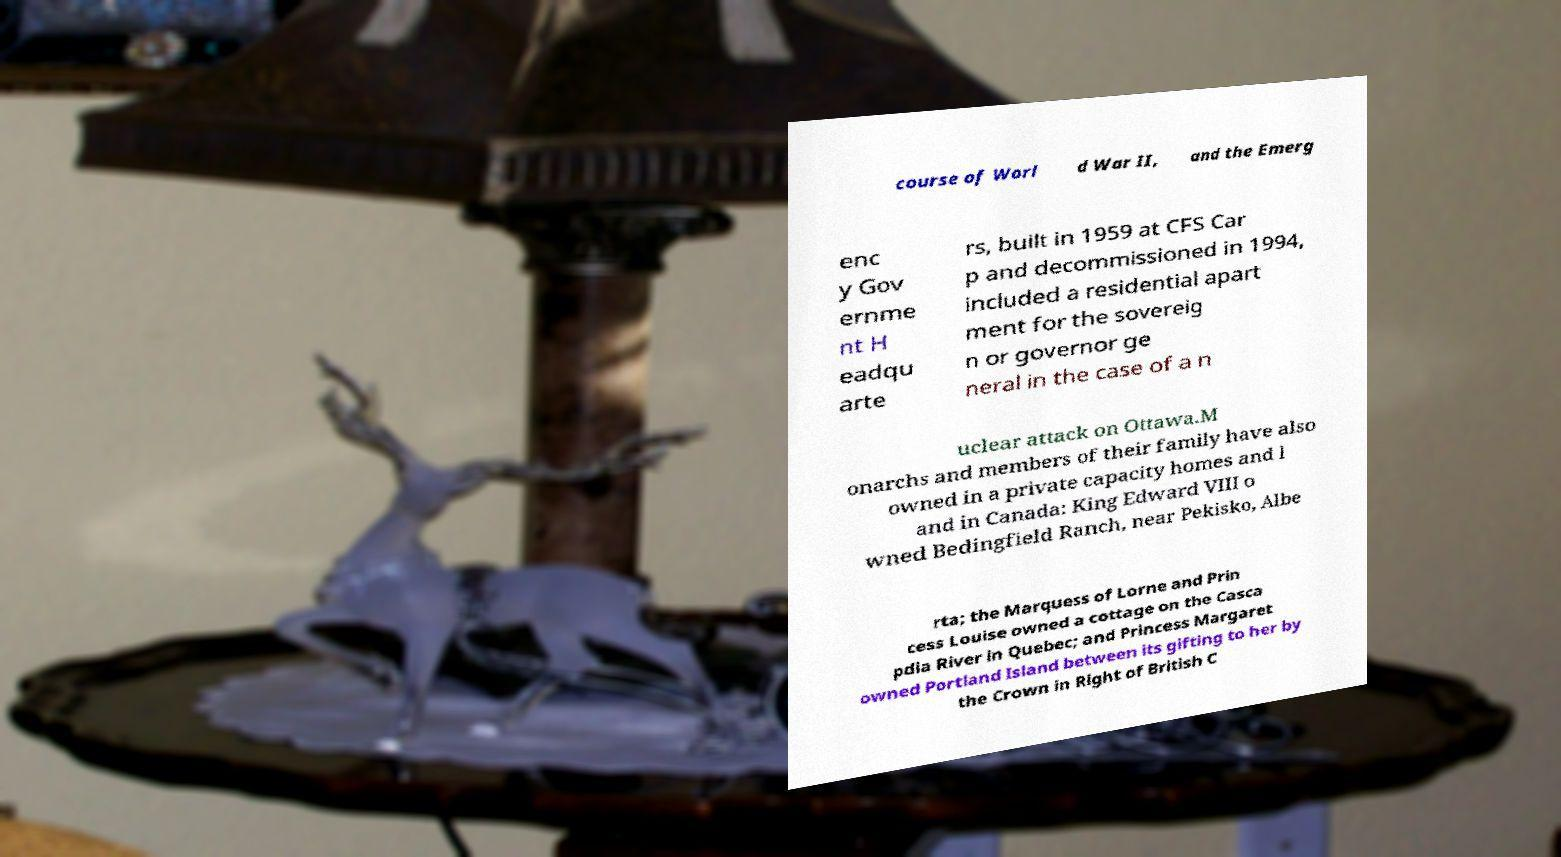Could you assist in decoding the text presented in this image and type it out clearly? course of Worl d War II, and the Emerg enc y Gov ernme nt H eadqu arte rs, built in 1959 at CFS Car p and decommissioned in 1994, included a residential apart ment for the sovereig n or governor ge neral in the case of a n uclear attack on Ottawa.M onarchs and members of their family have also owned in a private capacity homes and l and in Canada: King Edward VIII o wned Bedingfield Ranch, near Pekisko, Albe rta; the Marquess of Lorne and Prin cess Louise owned a cottage on the Casca pdia River in Quebec; and Princess Margaret owned Portland Island between its gifting to her by the Crown in Right of British C 